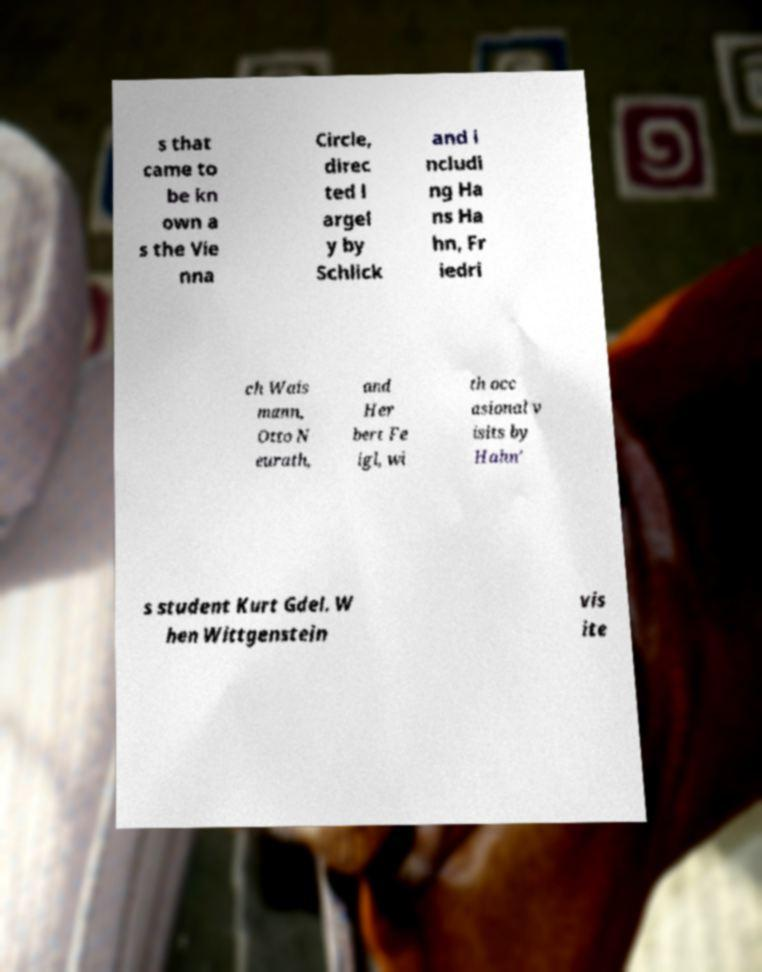There's text embedded in this image that I need extracted. Can you transcribe it verbatim? s that came to be kn own a s the Vie nna Circle, direc ted l argel y by Schlick and i ncludi ng Ha ns Ha hn, Fr iedri ch Wais mann, Otto N eurath, and Her bert Fe igl, wi th occ asional v isits by Hahn' s student Kurt Gdel. W hen Wittgenstein vis ite 